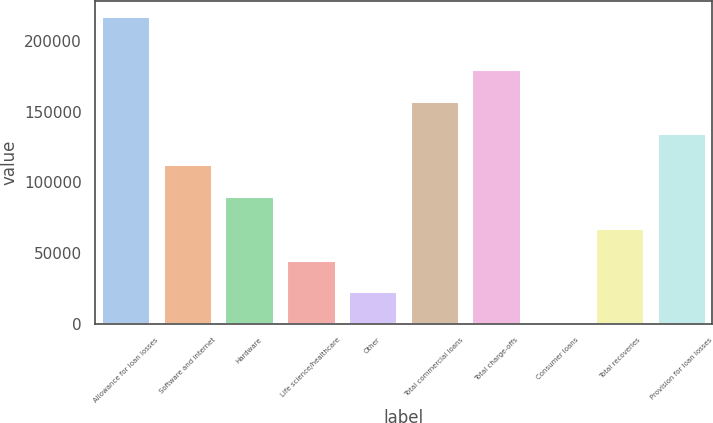<chart> <loc_0><loc_0><loc_500><loc_500><bar_chart><fcel>Allowance for loan losses<fcel>Software and internet<fcel>Hardware<fcel>Life science/healthcare<fcel>Other<fcel>Total commercial loans<fcel>Total charge-offs<fcel>Consumer loans<fcel>Total recoveries<fcel>Provision for loan losses<nl><fcel>217613<fcel>112812<fcel>90301.2<fcel>45279.6<fcel>22768.8<fcel>157834<fcel>180344<fcel>258<fcel>67790.4<fcel>135323<nl></chart> 